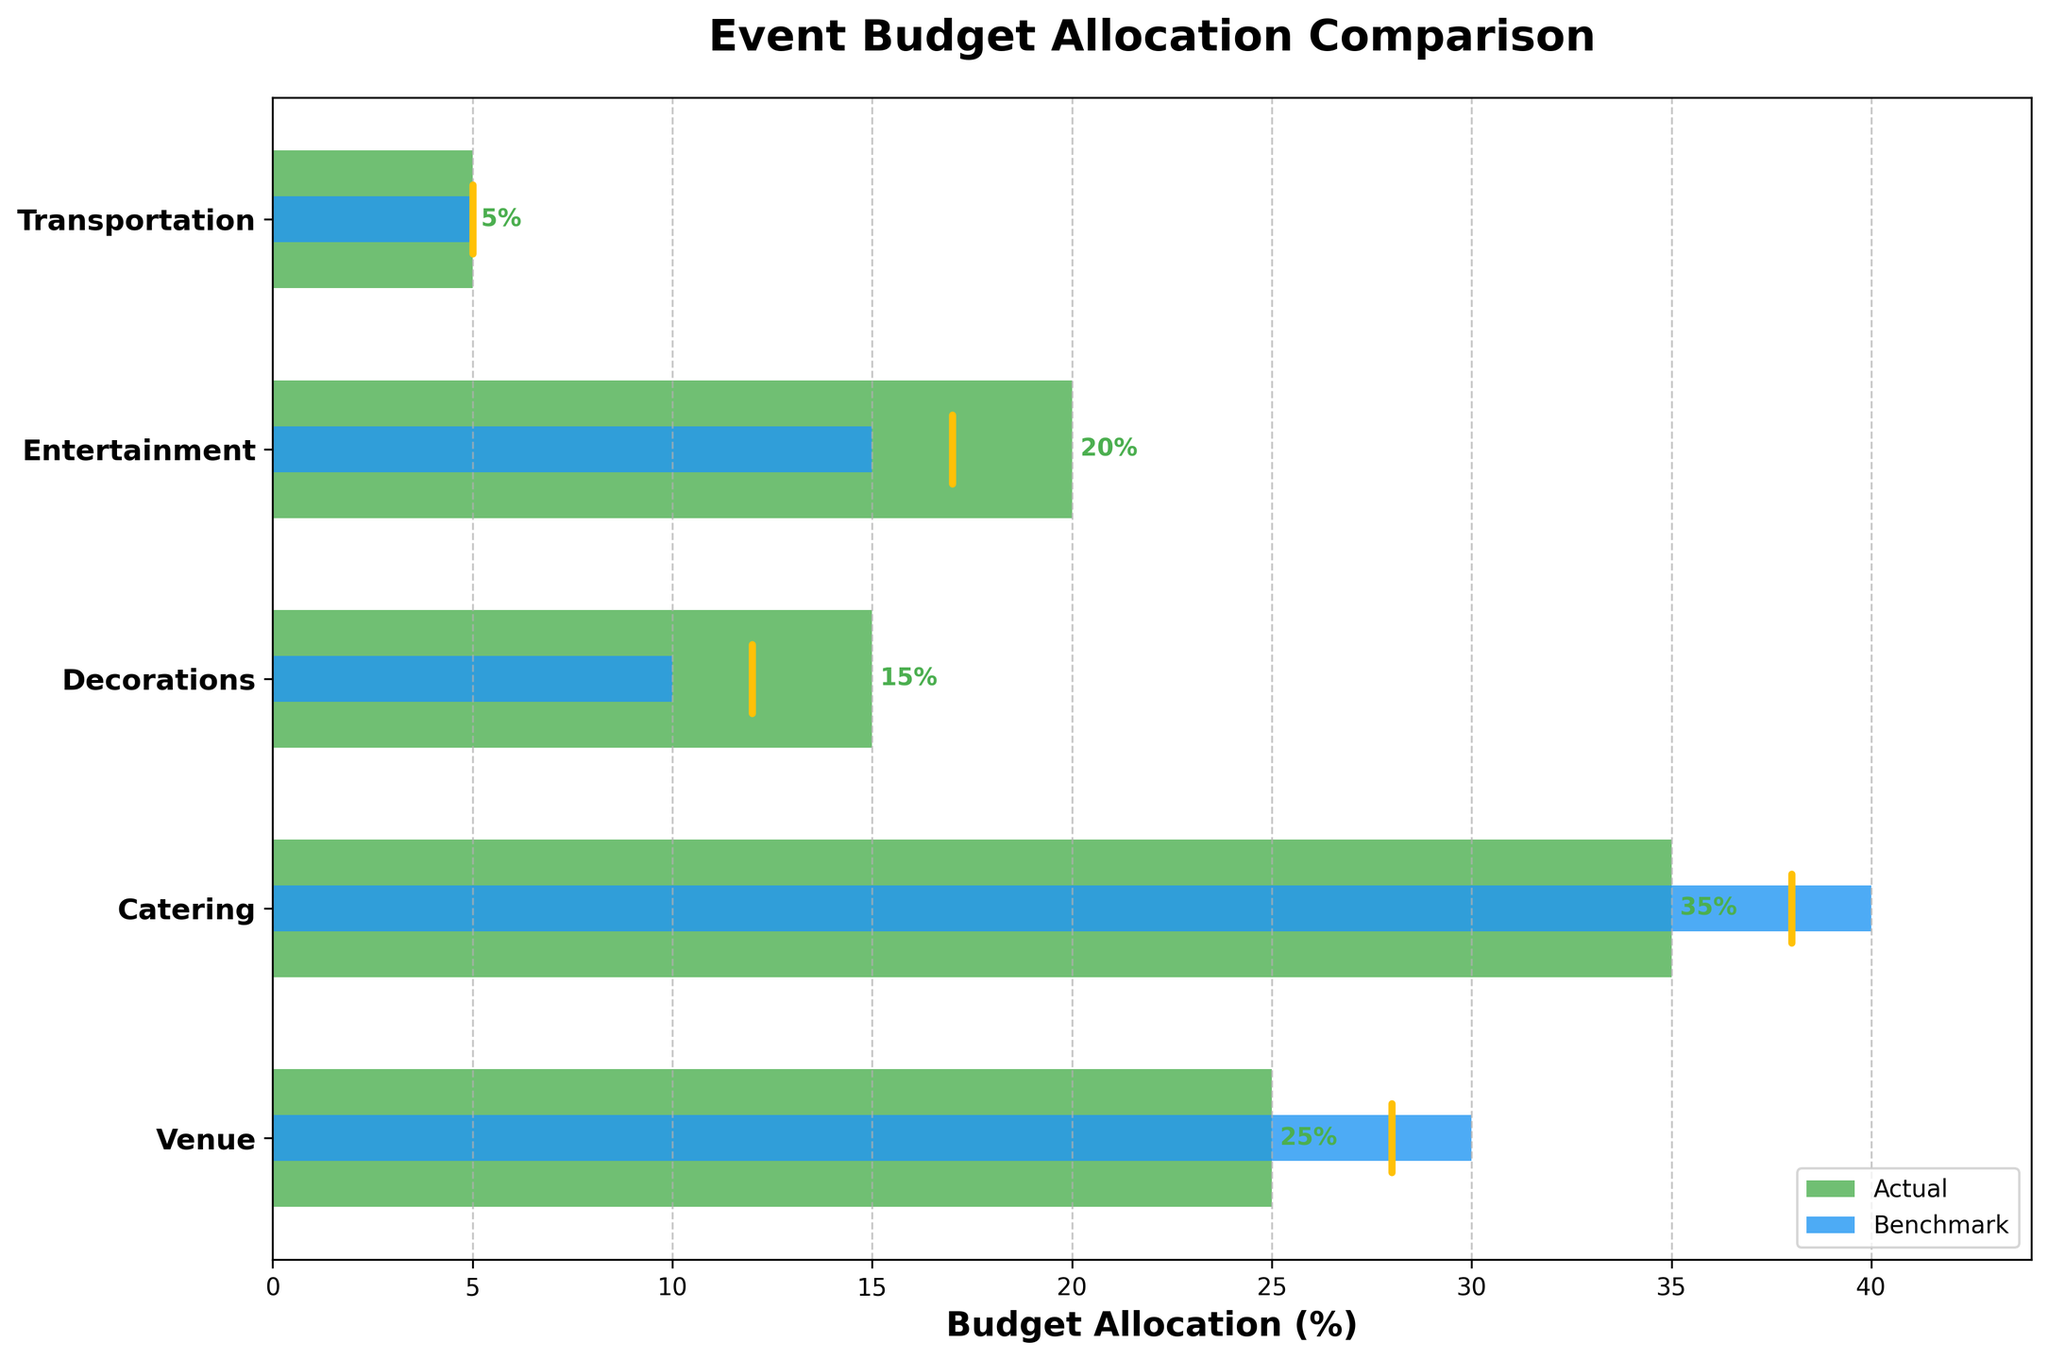Which budget category has the highest actual allocation? The highest actual allocation category is identified by the tallest green bar in the chart.
Answer: Catering What is the title of the chart? The title of the chart is the text displayed at the top center of the figure.
Answer: Event Budget Allocation Comparison How much does the actual allocation for entertainment exceed its target allocation? From the bar and target line for entertainment, the actual allocation is 20%, and the target is 17%. The difference is 20 - 17 = 3%.
Answer: 3% Which category has an actual budget allocation that is under its benchmark by the greatest amount? Compare the lengths of the green bars and blue benchmarks for each category. The category with the largest negative difference is catering (35% actual, 40% benchmark). 40 - 35 = 5.
Answer: Catering Is the transportation budget allocation meeting its benchmark and target? Check the green bar and both the benchmark and target lines for transportation. All are at 5%.
Answer: Yes What is the actual budget allocation for venue, and how does it compare to the benchmark? The green bar corresponding to the venue category shows 25%, and the benchmark (blue) bar shows 30%. Venue allocation is 25%, which is 5% less than the benchmark.
Answer: 25%, 5% less than the benchmark How does the actual allocation for decorations compare to its target and benchmark? The green bar for decorations shows 15%. The yellow line (target) is at 12%, and the blue bar (benchmark) is at 10%. The actual allocation exceeds the target by 3% (15 - 12) and the benchmark by 5% (15 - 10).
Answer: 3% above target, 5% above benchmark Which category's actual budget is exactly equal to its benchmark? Check for categories where the green and blue bars are of equal length. Transportation's actual allocation is 5%, equal to its benchmark.
Answer: Transportation What is the average target allocation percentage across all categories? Sum all the target percentages: 28 + 38 + 12 + 17 + 5 = 100. Divide by the number of categories (5). The average is 100 / 5 = 20%.
Answer: 20% Which categories have actual allocations above their respective targets? Compare the green bars and yellow lines for each category. Venue (25% vs. 28%) and catering (35% vs. 38%) are below, while decorations (15% vs. 12%) and entertainment (20% vs. 17%) are above. Transportation is equal.
Answer: Decorations, Entertainment 